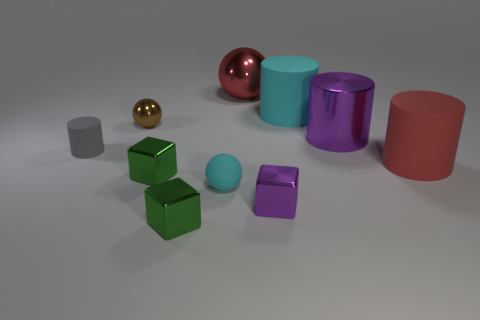What shape is the red object that is on the right side of the large metal object in front of the large cyan rubber object?
Make the answer very short. Cylinder. Are there fewer cyan matte cylinders that are on the right side of the large red ball than rubber spheres that are behind the small purple metal block?
Ensure brevity in your answer.  No. There is another big thing that is the same shape as the brown thing; what color is it?
Make the answer very short. Red. What number of large red things are on the left side of the purple shiny cylinder and in front of the gray rubber thing?
Offer a terse response. 0. Is the number of big purple cylinders behind the small shiny ball greater than the number of small objects that are in front of the small gray cylinder?
Offer a terse response. No. How big is the brown metallic thing?
Provide a succinct answer. Small. Are there any big red things of the same shape as the small cyan rubber thing?
Provide a short and direct response. Yes. There is a small gray thing; is its shape the same as the cyan rubber object on the left side of the red shiny object?
Give a very brief answer. No. There is a metallic object that is behind the gray thing and left of the small matte ball; what is its size?
Make the answer very short. Small. What number of gray cylinders are there?
Offer a very short reply. 1. 